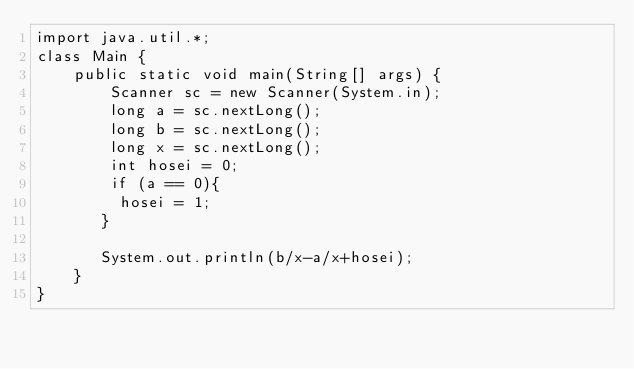Convert code to text. <code><loc_0><loc_0><loc_500><loc_500><_Java_>import java.util.*;
class Main {
    public static void main(String[] args) {
        Scanner sc = new Scanner(System.in);
        long a = sc.nextLong();
        long b = sc.nextLong();
        long x = sc.nextLong();
        int hosei = 0;
        if (a == 0){
         hosei = 1;
       }
        
       System.out.println(b/x-a/x+hosei);
    }
}
</code> 